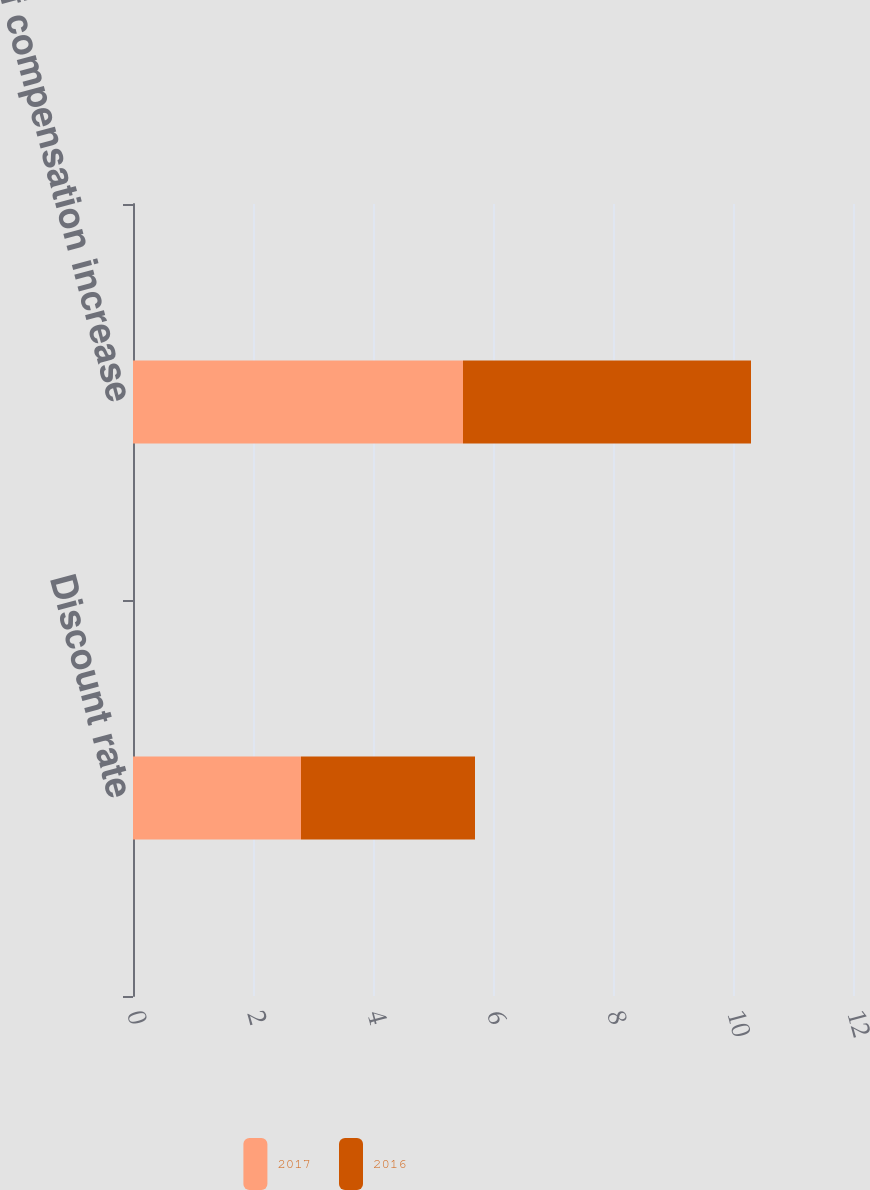Convert chart to OTSL. <chart><loc_0><loc_0><loc_500><loc_500><stacked_bar_chart><ecel><fcel>Discount rate<fcel>Rate of compensation increase<nl><fcel>2017<fcel>2.8<fcel>5.5<nl><fcel>2016<fcel>2.9<fcel>4.8<nl></chart> 